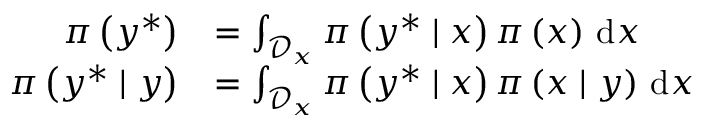Convert formula to latex. <formula><loc_0><loc_0><loc_500><loc_500>\begin{array} { r l } { \pi \left ( y ^ { \ast } \right ) } & { = \int _ { \mathcal { D } _ { x } } \pi \left ( y ^ { \ast } | x \right ) \pi \left ( x \right ) \, d x } \\ { \pi \left ( y ^ { \ast } | y \right ) } & { = \int _ { \mathcal { D } _ { x } } \pi \left ( y ^ { \ast } | x \right ) \pi \left ( x | y \right ) \, d x } \end{array}</formula> 